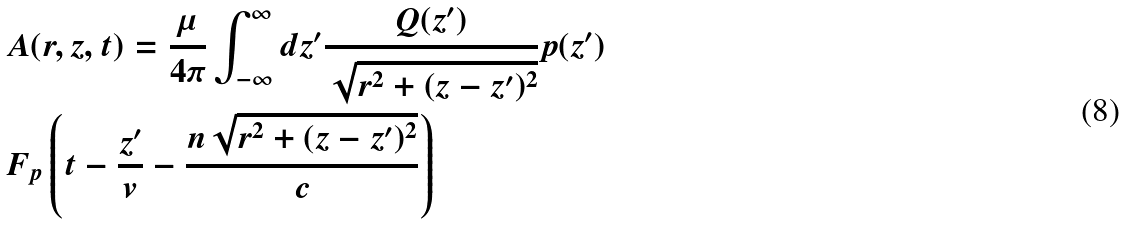<formula> <loc_0><loc_0><loc_500><loc_500>& A ( r , z , t ) = \frac { \mu } { 4 \pi } \int _ { - \infty } ^ { \infty } d z ^ { \prime } \frac { Q ( z ^ { \prime } ) } { \sqrt { r ^ { 2 } + ( z - z ^ { \prime } ) ^ { 2 } } } p ( z ^ { \prime } ) \\ & F _ { p } \left ( t - \frac { z ^ { \prime } } { v } - \frac { n \sqrt { r ^ { 2 } + ( z - z ^ { \prime } ) ^ { 2 } } } { c } \right )</formula> 